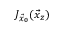<formula> <loc_0><loc_0><loc_500><loc_500>J _ { \vec { x } _ { 0 } } ( \vec { x } _ { z } )</formula> 